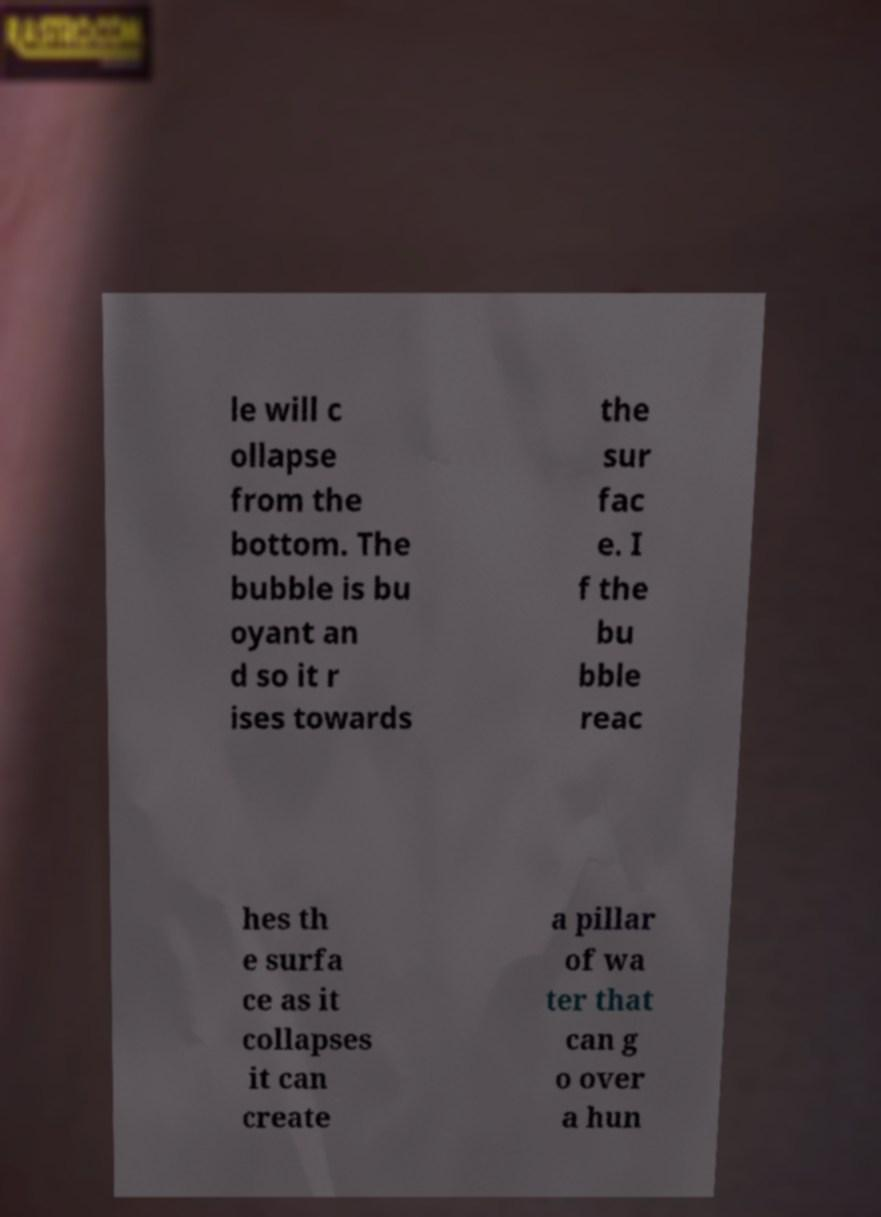Could you extract and type out the text from this image? le will c ollapse from the bottom. The bubble is bu oyant an d so it r ises towards the sur fac e. I f the bu bble reac hes th e surfa ce as it collapses it can create a pillar of wa ter that can g o over a hun 